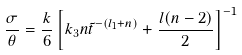<formula> <loc_0><loc_0><loc_500><loc_500>\frac { \sigma } { \theta } = \frac { k } { 6 } \left [ k _ { 3 } n { \tilde { t } } ^ { - ( l _ { 1 } + n ) } + \frac { l ( n - 2 ) } { 2 } \right ] ^ { - 1 }</formula> 